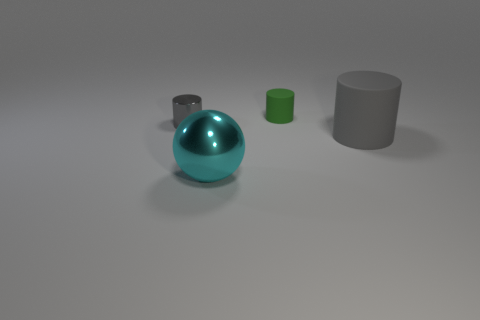Are the tiny green cylinder that is behind the cyan object and the cylinder left of the large sphere made of the same material? It's not possible to determine if the materials are identical just by visual inspection, but they do appear to have different surface finishes, suggesting that they might be made from varied materials. The tiny green cylinder has a matte finish, while the cylinder to the left of the large sphere has a reflective surface. 